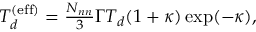<formula> <loc_0><loc_0><loc_500><loc_500>\begin{array} { r } { T _ { d } ^ { ( e f f ) } = \frac { N _ { n n } } { 3 } \Gamma T _ { d } ( 1 + \kappa ) \exp ( - \kappa ) , } \end{array}</formula> 